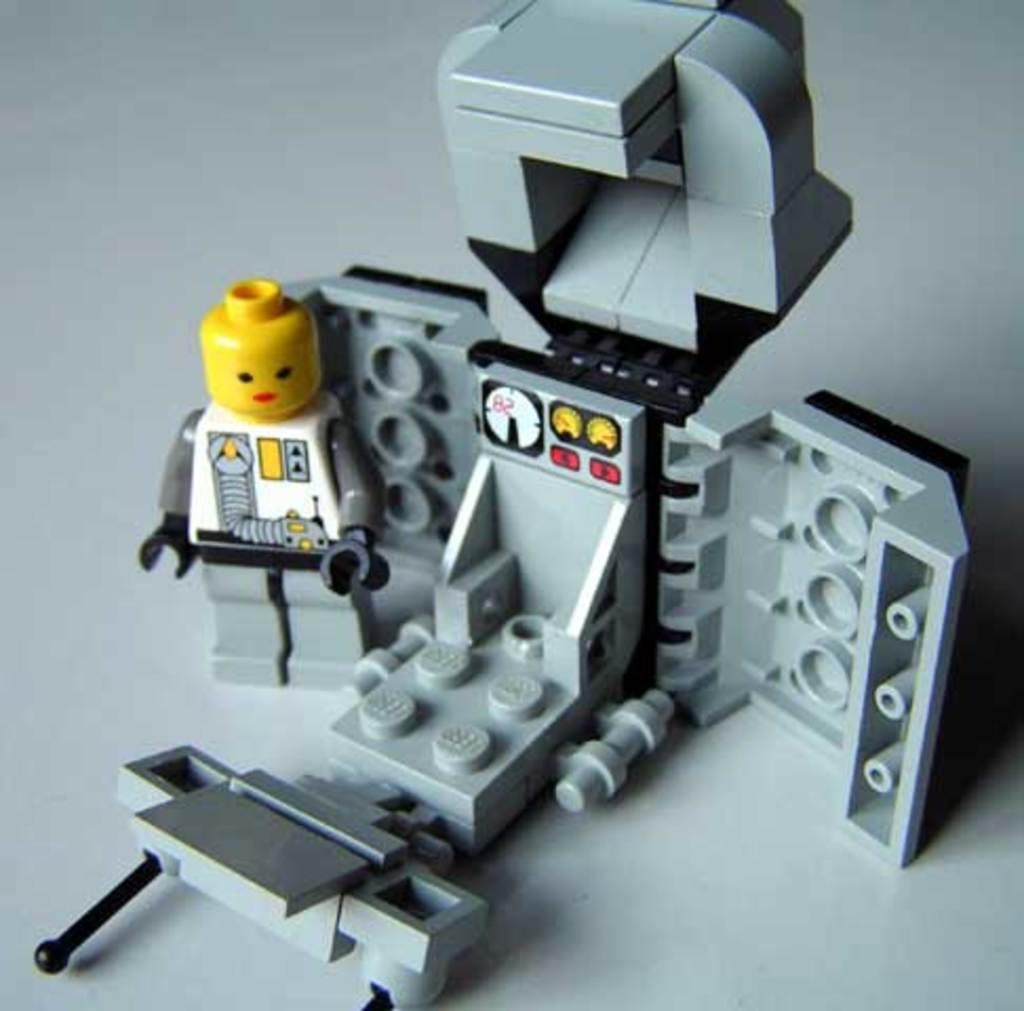What type of objects are in the image? There are toys in the image. What material are the toys made of? The toys are made of Lego bricks. Where are the toys located in the image? The toys are on a surface. What type of cart is being used to transport the toys in the image? There is no cart present in the image; the toys are on a surface. Can you tell me who is having an argument with the actor in the image? There is no argument or actor present in the image; it features toys made of Lego bricks on a surface. 